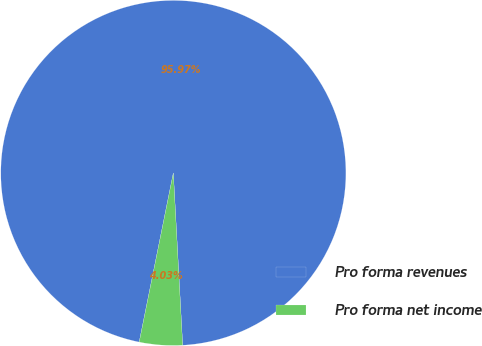<chart> <loc_0><loc_0><loc_500><loc_500><pie_chart><fcel>Pro forma revenues<fcel>Pro forma net income<nl><fcel>95.97%<fcel>4.03%<nl></chart> 